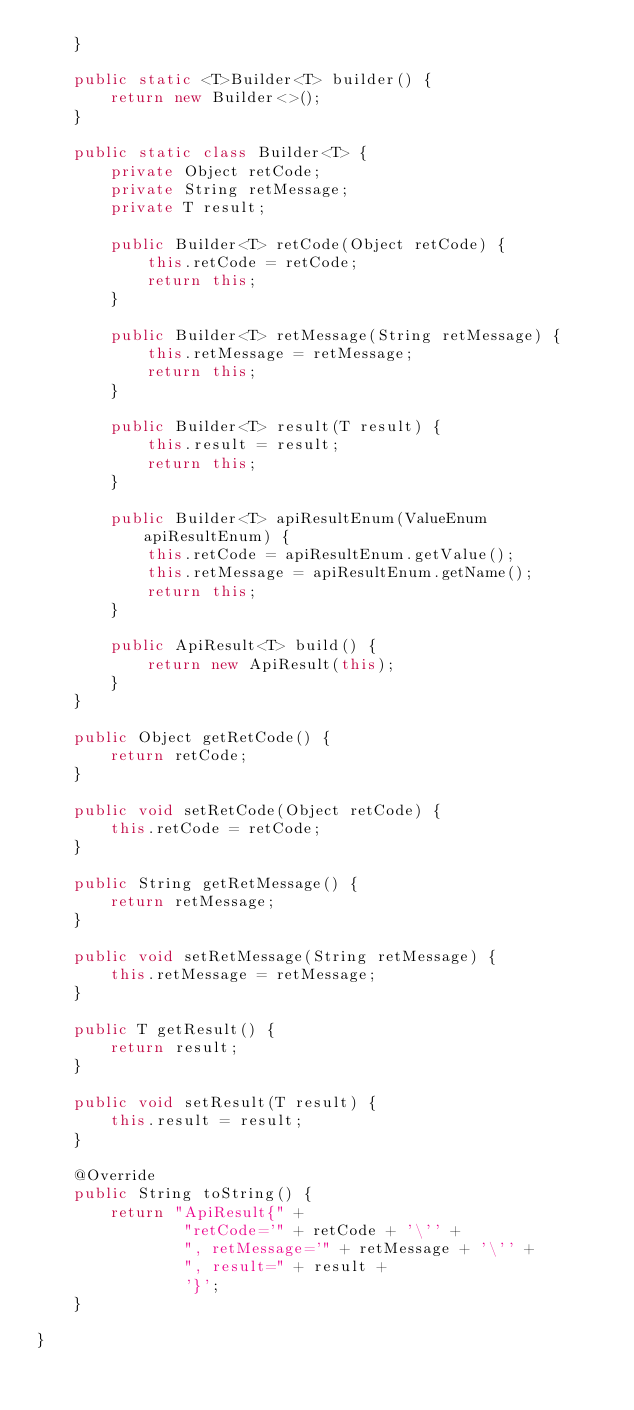Convert code to text. <code><loc_0><loc_0><loc_500><loc_500><_Java_>    }

    public static <T>Builder<T> builder() {
        return new Builder<>();
    }

    public static class Builder<T> {
        private Object retCode;
        private String retMessage;
        private T result;

        public Builder<T> retCode(Object retCode) {
            this.retCode = retCode;
            return this;
        }

        public Builder<T> retMessage(String retMessage) {
            this.retMessage = retMessage;
            return this;
        }

        public Builder<T> result(T result) {
            this.result = result;
            return this;
        }

        public Builder<T> apiResultEnum(ValueEnum apiResultEnum) {
            this.retCode = apiResultEnum.getValue();
            this.retMessage = apiResultEnum.getName();
            return this;
        }

        public ApiResult<T> build() {
            return new ApiResult(this);
        }
    }

    public Object getRetCode() {
        return retCode;
    }

    public void setRetCode(Object retCode) {
        this.retCode = retCode;
    }

    public String getRetMessage() {
        return retMessage;
    }

    public void setRetMessage(String retMessage) {
        this.retMessage = retMessage;
    }

    public T getResult() {
        return result;
    }

    public void setResult(T result) {
        this.result = result;
    }

    @Override
    public String toString() {
        return "ApiResult{" +
                "retCode='" + retCode + '\'' +
                ", retMessage='" + retMessage + '\'' +
                ", result=" + result +
                '}';
    }

}
</code> 